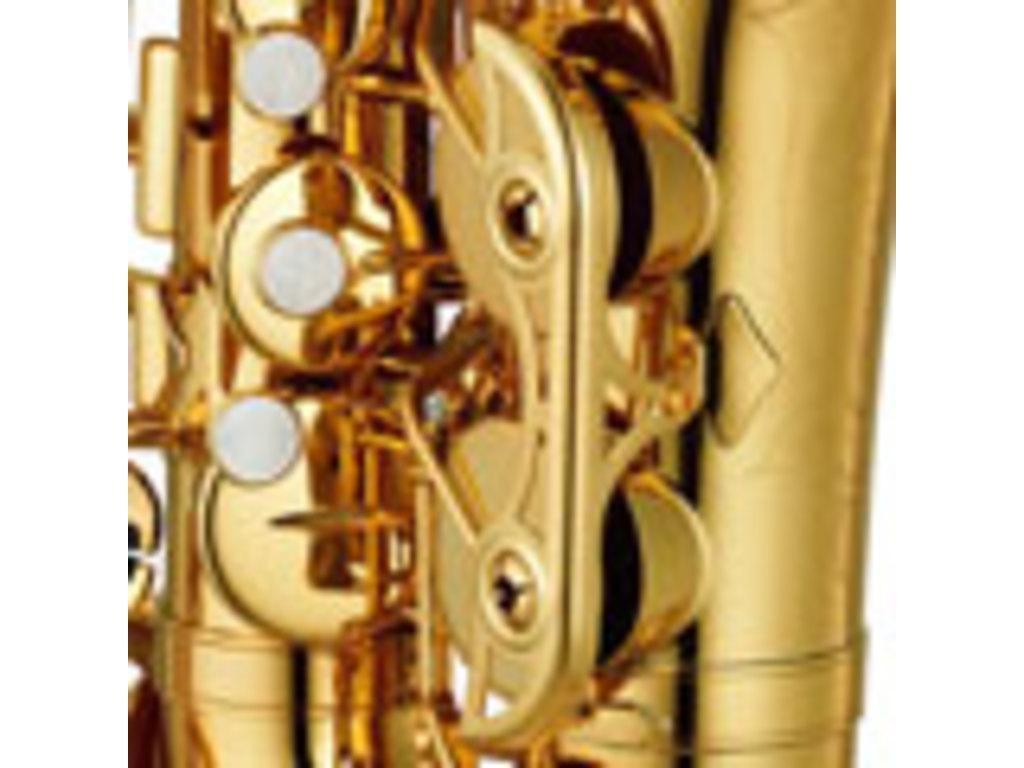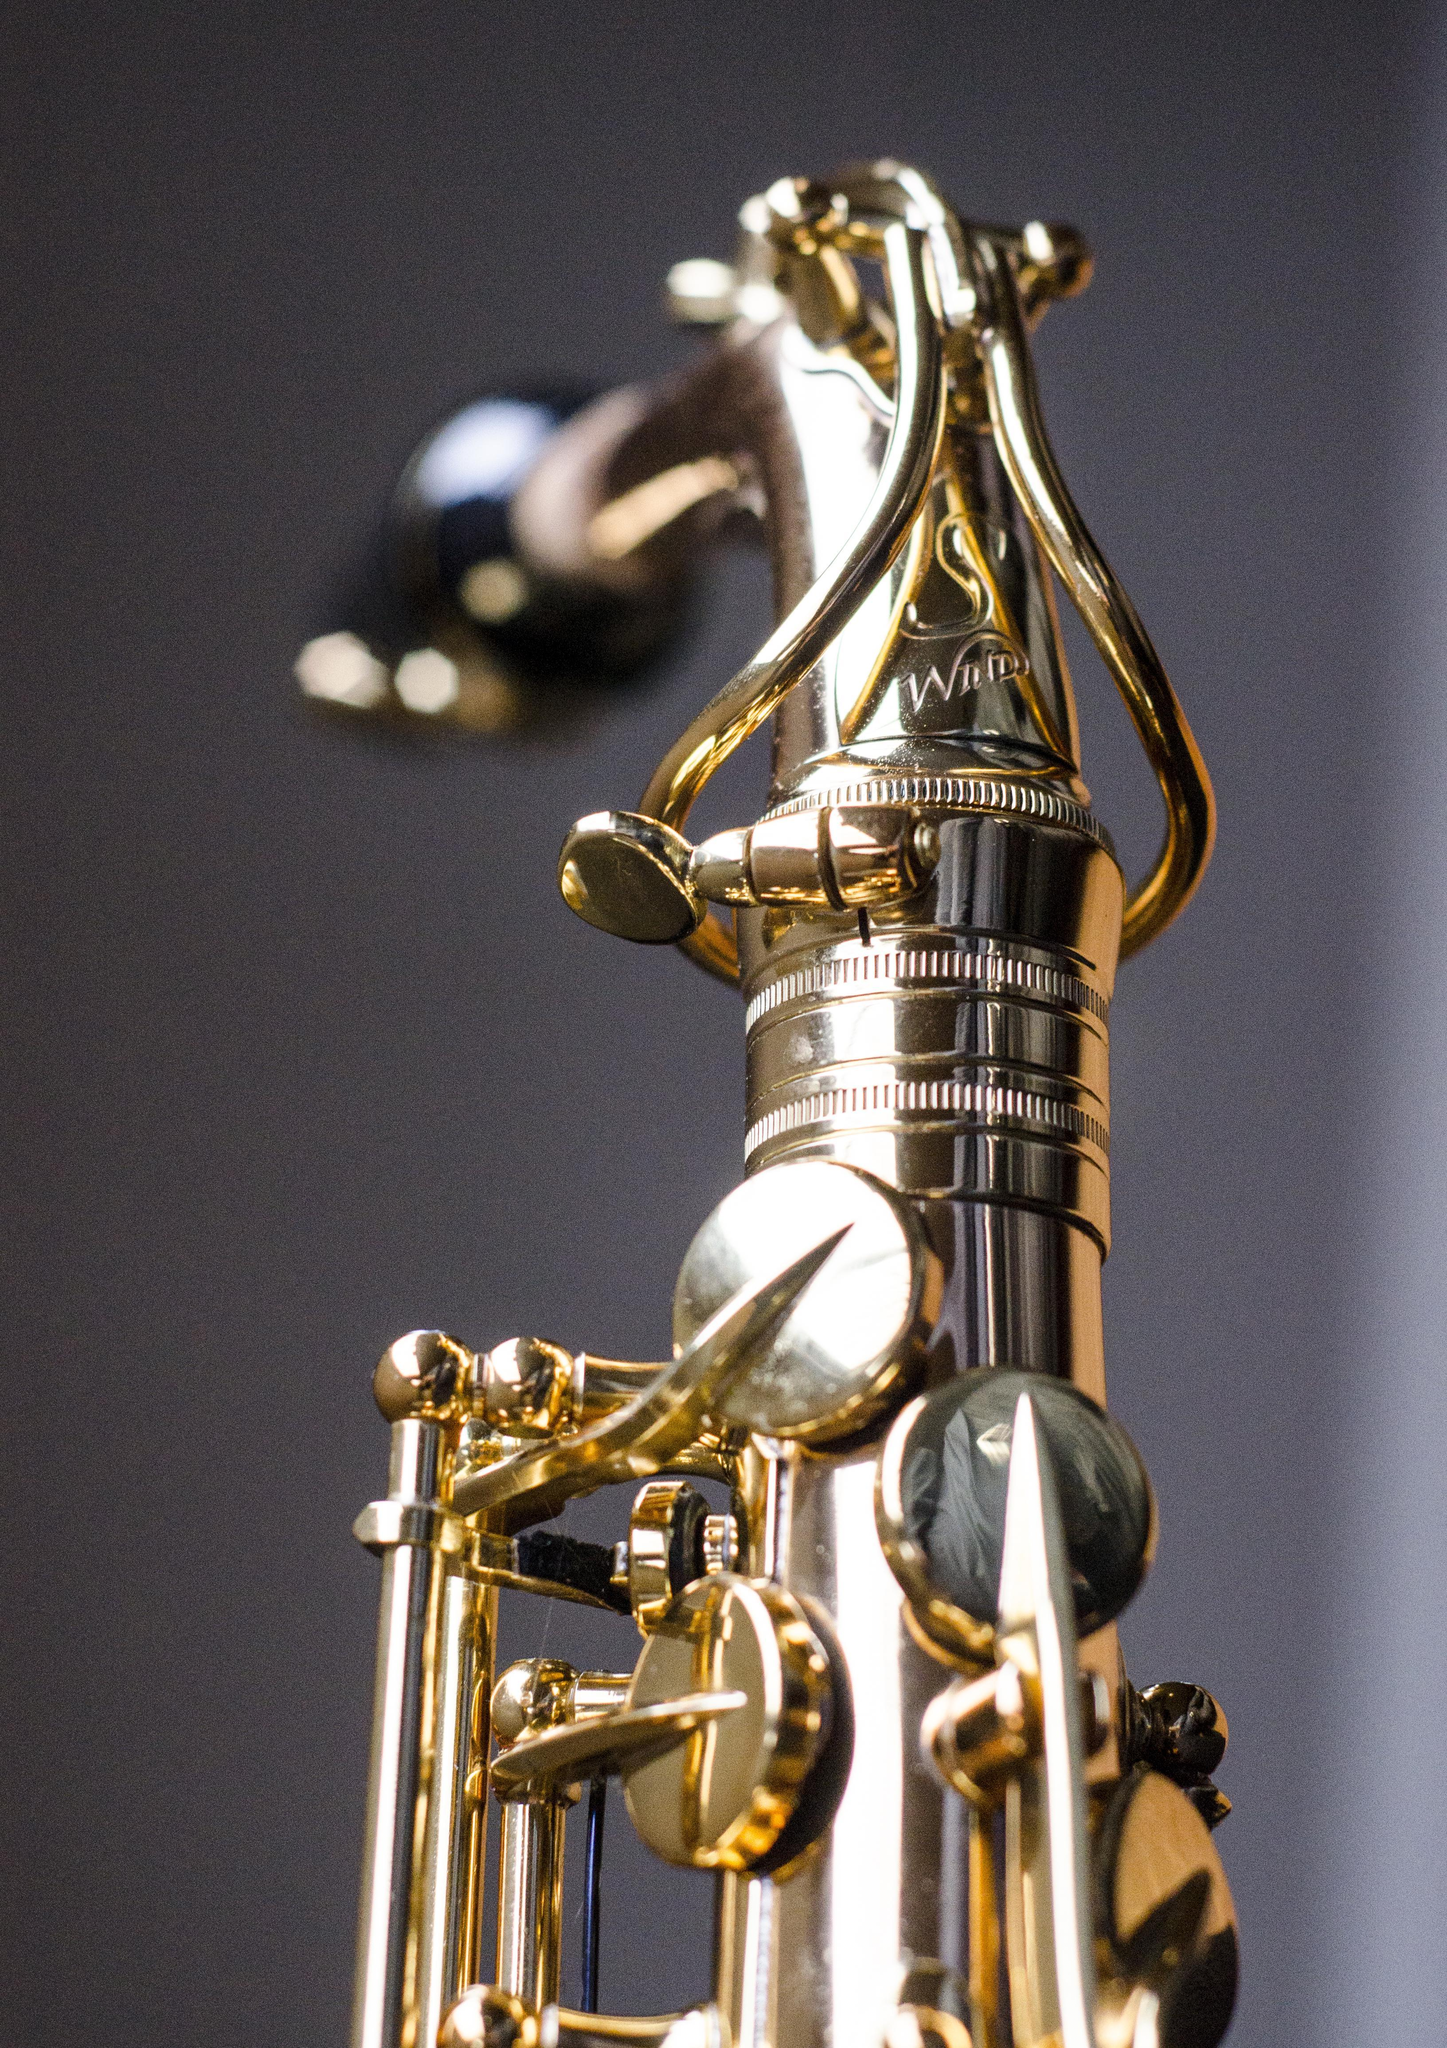The first image is the image on the left, the second image is the image on the right. Considering the images on both sides, is "At least one image shows a saxophone displayed on a rich orange-red fabric." valid? Answer yes or no. No. 